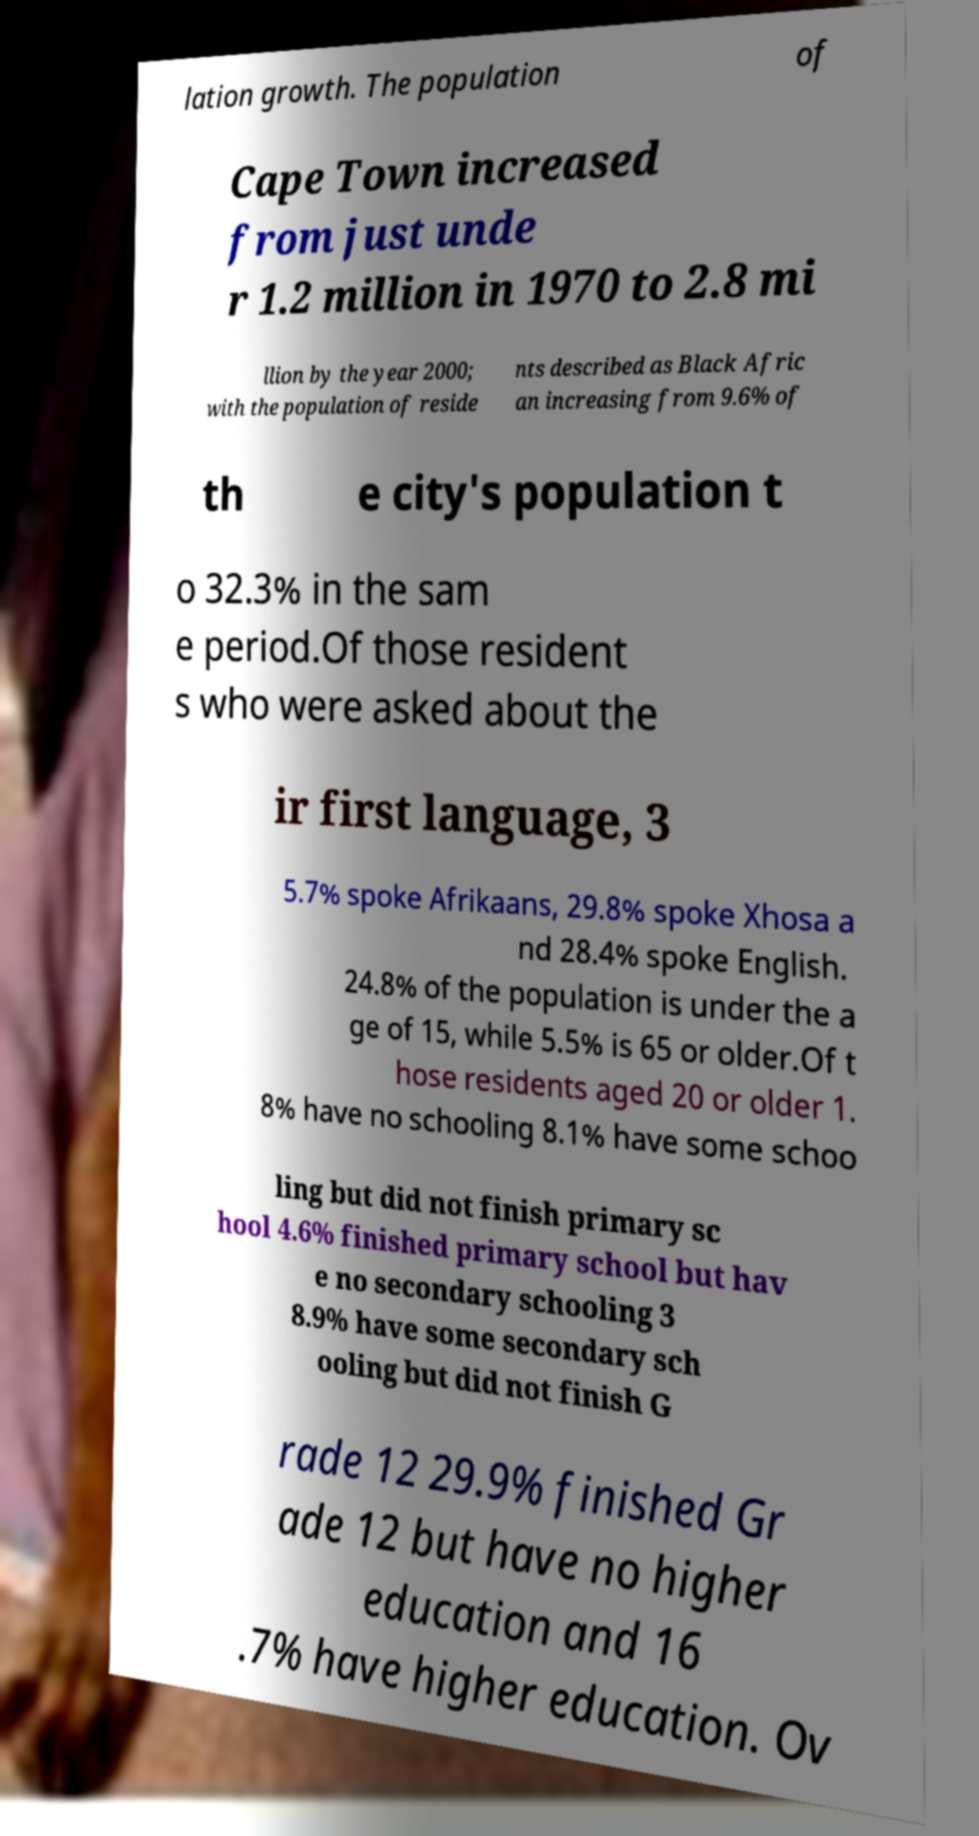Could you extract and type out the text from this image? lation growth. The population of Cape Town increased from just unde r 1.2 million in 1970 to 2.8 mi llion by the year 2000; with the population of reside nts described as Black Afric an increasing from 9.6% of th e city's population t o 32.3% in the sam e period.Of those resident s who were asked about the ir first language, 3 5.7% spoke Afrikaans, 29.8% spoke Xhosa a nd 28.4% spoke English. 24.8% of the population is under the a ge of 15, while 5.5% is 65 or older.Of t hose residents aged 20 or older 1. 8% have no schooling 8.1% have some schoo ling but did not finish primary sc hool 4.6% finished primary school but hav e no secondary schooling 3 8.9% have some secondary sch ooling but did not finish G rade 12 29.9% finished Gr ade 12 but have no higher education and 16 .7% have higher education. Ov 